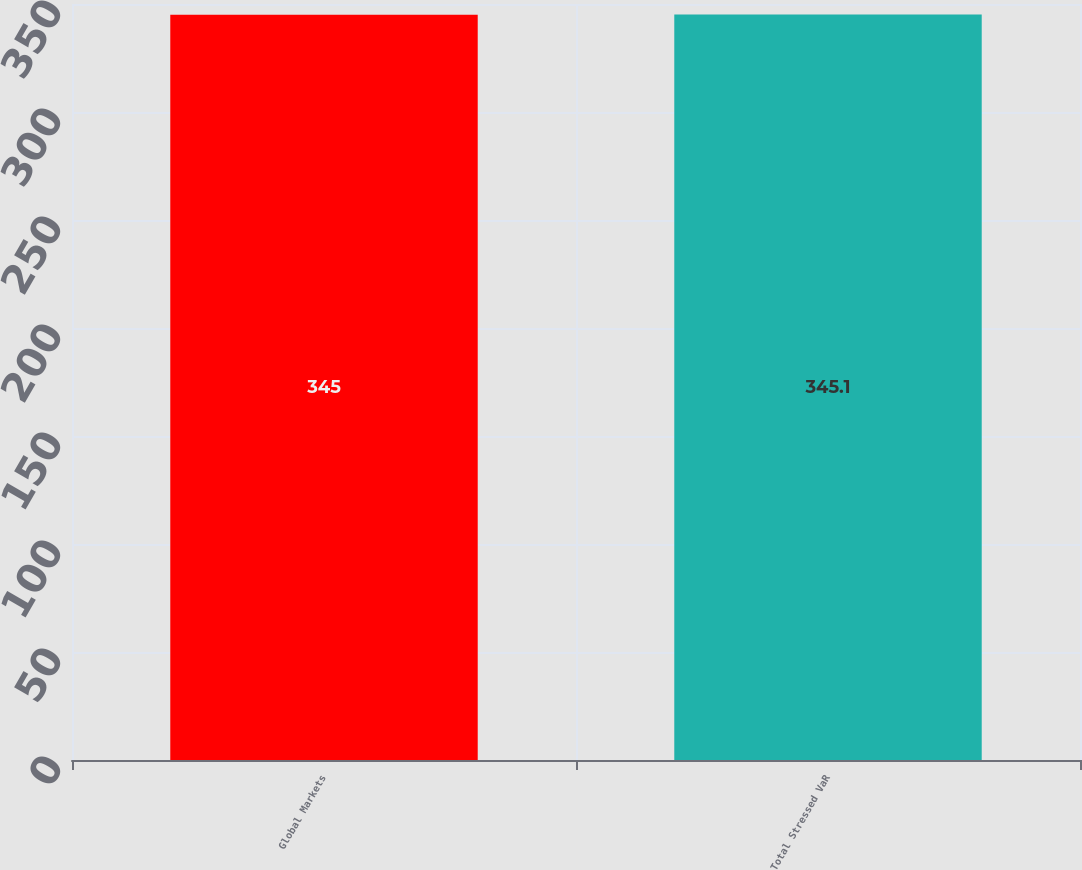Convert chart. <chart><loc_0><loc_0><loc_500><loc_500><bar_chart><fcel>Global Markets<fcel>Total Stressed VaR<nl><fcel>345<fcel>345.1<nl></chart> 